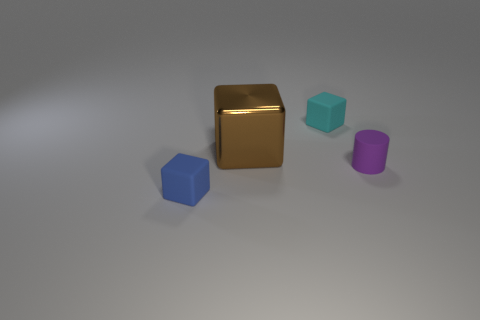Add 4 small blue rubber blocks. How many objects exist? 8 Subtract all blocks. How many objects are left? 1 Add 4 small purple matte cylinders. How many small purple matte cylinders exist? 5 Subtract 0 gray blocks. How many objects are left? 4 Subtract all big shiny cubes. Subtract all large purple metal blocks. How many objects are left? 3 Add 4 small cyan matte blocks. How many small cyan matte blocks are left? 5 